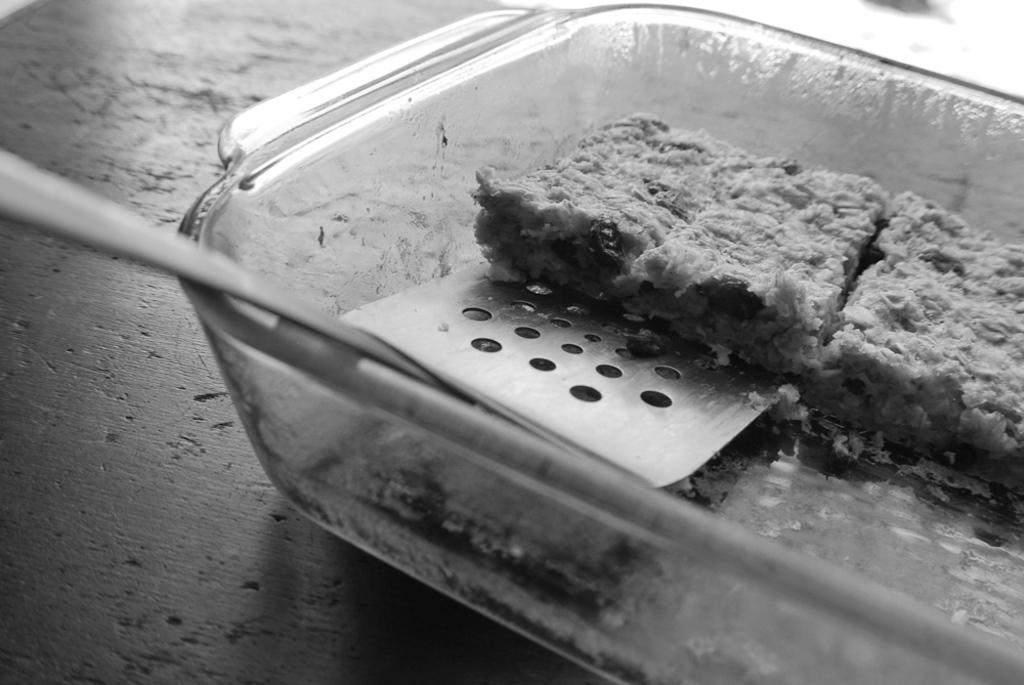What is the color scheme of the image? The image is black and white. What object is present in the image that is made of glass? There is a glass bowl in the image. What is inside the glass bowl? The glass bowl contains a food item. What utensil is visible in the image? There is a spoon in the image. Can you see any ocean waves in the image? There is no ocean or waves present in the image; it is a black and white image featuring a glass bowl with a food item and a spoon. 